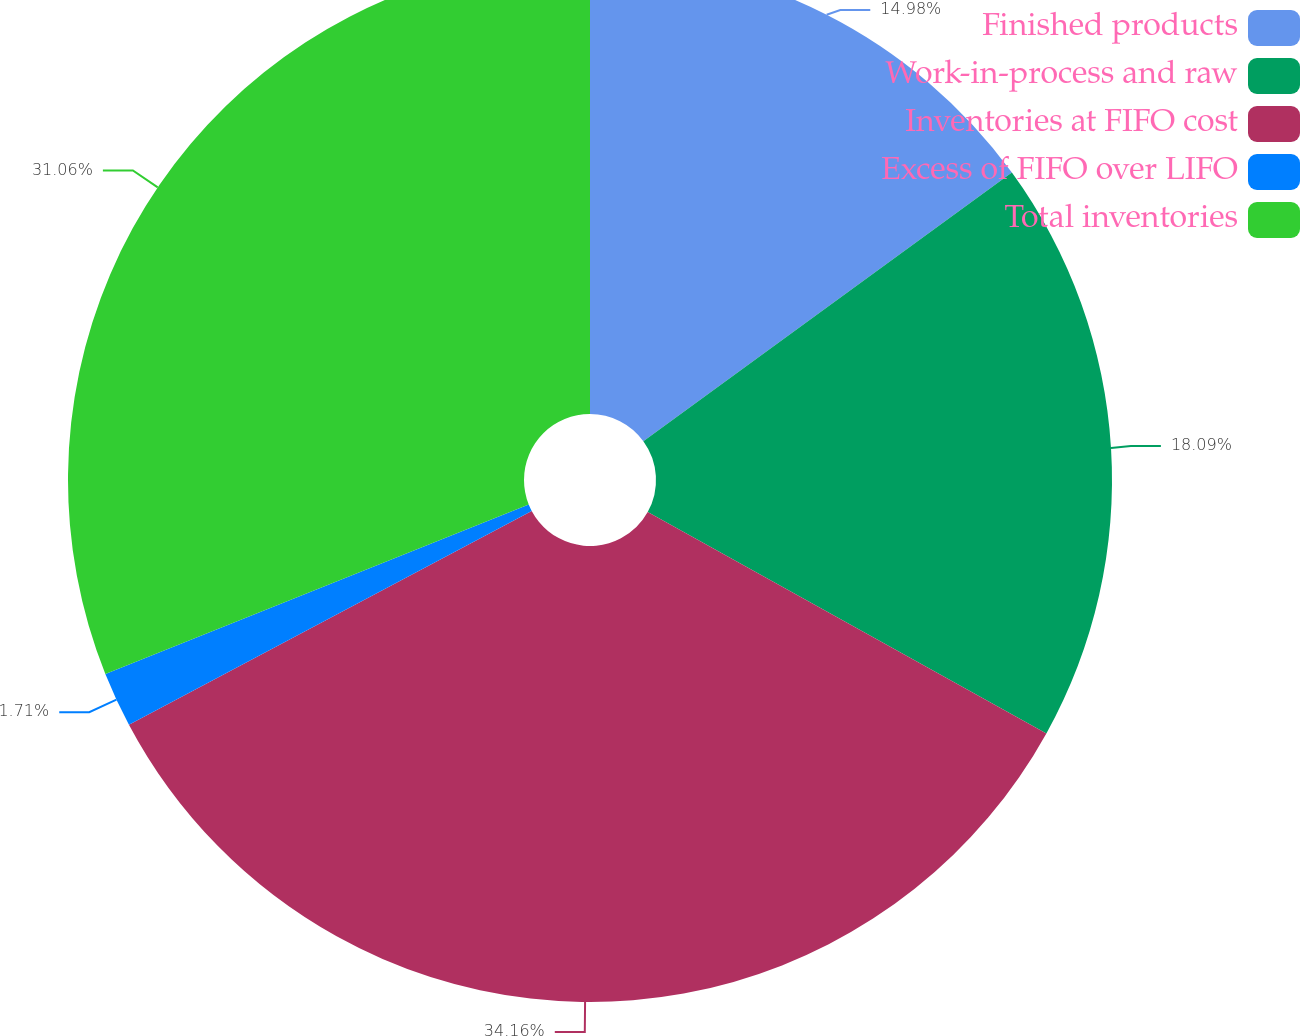<chart> <loc_0><loc_0><loc_500><loc_500><pie_chart><fcel>Finished products<fcel>Work-in-process and raw<fcel>Inventories at FIFO cost<fcel>Excess of FIFO over LIFO<fcel>Total inventories<nl><fcel>14.98%<fcel>18.09%<fcel>34.17%<fcel>1.71%<fcel>31.06%<nl></chart> 